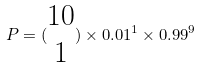<formula> <loc_0><loc_0><loc_500><loc_500>P = ( \begin{matrix} 1 0 \\ 1 \end{matrix} ) \times 0 . 0 1 ^ { 1 } \times 0 . 9 9 ^ { 9 }</formula> 